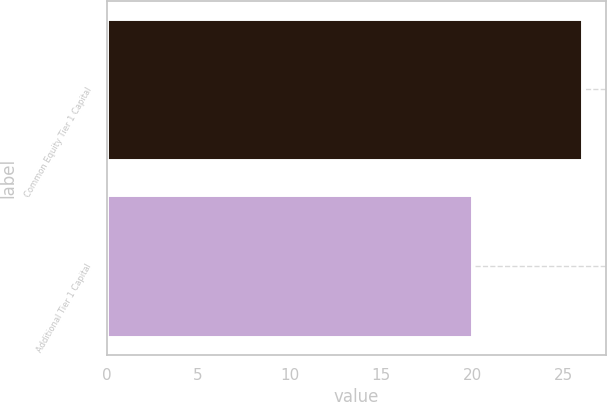<chart> <loc_0><loc_0><loc_500><loc_500><bar_chart><fcel>Common Equity Tier 1 Capital<fcel>Additional Tier 1 Capital<nl><fcel>26<fcel>20<nl></chart> 